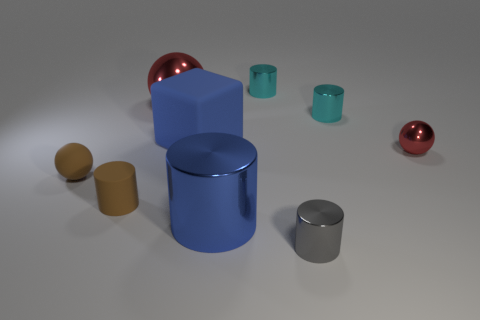Is the size of the brown ball the same as the blue rubber object?
Provide a succinct answer. No. Is the material of the tiny cylinder on the left side of the big cube the same as the tiny sphere that is to the right of the big blue metal object?
Provide a succinct answer. No. There is a red thing that is on the right side of the big blue object that is in front of the small sphere that is to the left of the blue rubber cube; what shape is it?
Provide a short and direct response. Sphere. Is the number of blue cylinders greater than the number of brown things?
Give a very brief answer. No. Are there any blue rubber objects?
Your response must be concise. Yes. How many objects are either objects left of the gray cylinder or small metal objects that are in front of the big metallic cylinder?
Provide a succinct answer. 7. Is the color of the big shiny cylinder the same as the cube?
Your response must be concise. Yes. Are there fewer big shiny objects than large blue cubes?
Your response must be concise. No. Are there any cylinders left of the brown ball?
Make the answer very short. No. Does the blue cube have the same material as the brown ball?
Keep it short and to the point. Yes. 